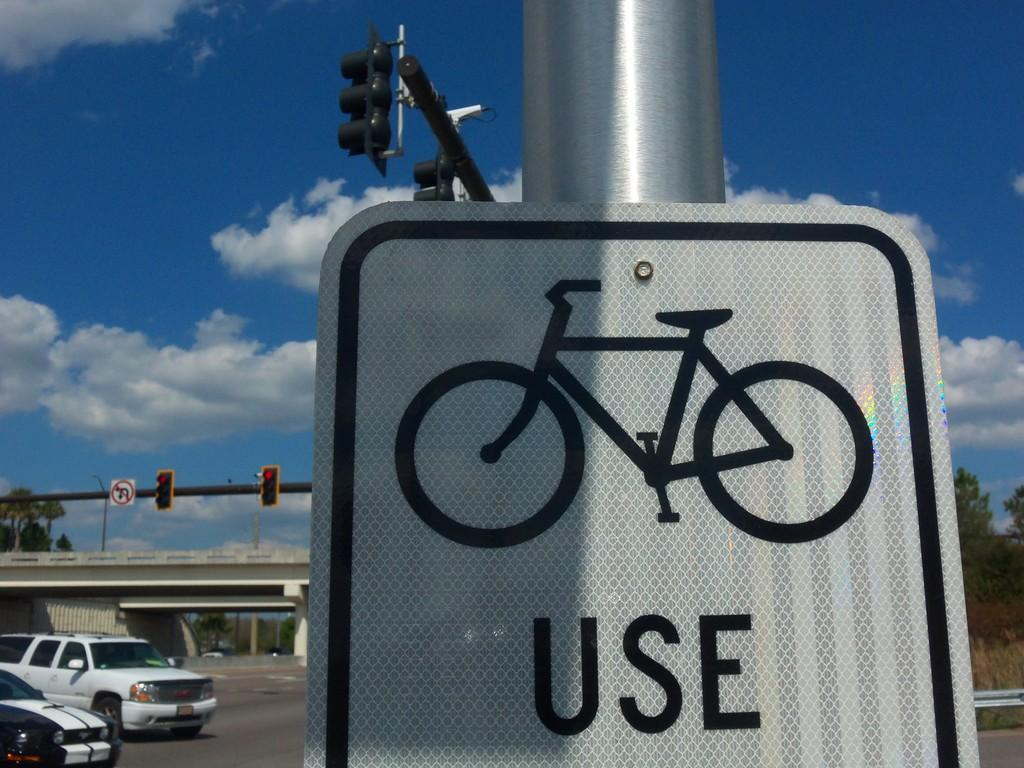Provide a one-sentence caption for the provided image. A sign with a bike and the word use on it hangs on a pole by a roadway. 